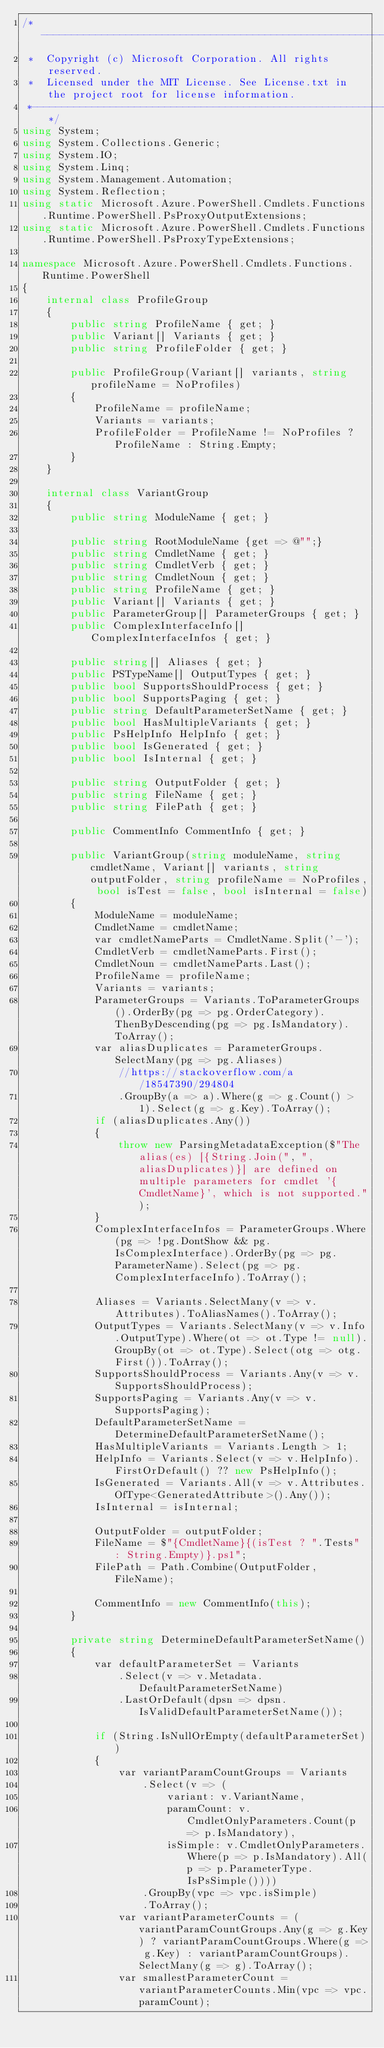Convert code to text. <code><loc_0><loc_0><loc_500><loc_500><_C#_>/*---------------------------------------------------------------------------------------------
 *  Copyright (c) Microsoft Corporation. All rights reserved.
 *  Licensed under the MIT License. See License.txt in the project root for license information.
 *--------------------------------------------------------------------------------------------*/
using System;
using System.Collections.Generic;
using System.IO;
using System.Linq;
using System.Management.Automation;
using System.Reflection;
using static Microsoft.Azure.PowerShell.Cmdlets.Functions.Runtime.PowerShell.PsProxyOutputExtensions;
using static Microsoft.Azure.PowerShell.Cmdlets.Functions.Runtime.PowerShell.PsProxyTypeExtensions;

namespace Microsoft.Azure.PowerShell.Cmdlets.Functions.Runtime.PowerShell
{
    internal class ProfileGroup
    {
        public string ProfileName { get; }
        public Variant[] Variants { get; }
        public string ProfileFolder { get; }

        public ProfileGroup(Variant[] variants, string profileName = NoProfiles)
        {
            ProfileName = profileName;
            Variants = variants;
            ProfileFolder = ProfileName != NoProfiles ? ProfileName : String.Empty;
        }
    }

    internal class VariantGroup
    {
        public string ModuleName { get; }

        public string RootModuleName {get => @"";}
        public string CmdletName { get; }
        public string CmdletVerb { get; }
        public string CmdletNoun { get; }
        public string ProfileName { get; }
        public Variant[] Variants { get; }
        public ParameterGroup[] ParameterGroups { get; }
        public ComplexInterfaceInfo[] ComplexInterfaceInfos { get; }

        public string[] Aliases { get; }
        public PSTypeName[] OutputTypes { get; }
        public bool SupportsShouldProcess { get; }
        public bool SupportsPaging { get; }
        public string DefaultParameterSetName { get; }
        public bool HasMultipleVariants { get; }
        public PsHelpInfo HelpInfo { get; }
        public bool IsGenerated { get; }
        public bool IsInternal { get; }

        public string OutputFolder { get; }
        public string FileName { get; }
        public string FilePath { get; }

        public CommentInfo CommentInfo { get; }

        public VariantGroup(string moduleName, string cmdletName, Variant[] variants, string outputFolder, string profileName = NoProfiles, bool isTest = false, bool isInternal = false)
        {
            ModuleName = moduleName;
            CmdletName = cmdletName;
            var cmdletNameParts = CmdletName.Split('-');
            CmdletVerb = cmdletNameParts.First();
            CmdletNoun = cmdletNameParts.Last();
            ProfileName = profileName;
            Variants = variants;
            ParameterGroups = Variants.ToParameterGroups().OrderBy(pg => pg.OrderCategory).ThenByDescending(pg => pg.IsMandatory).ToArray();
            var aliasDuplicates = ParameterGroups.SelectMany(pg => pg.Aliases)
                //https://stackoverflow.com/a/18547390/294804
                .GroupBy(a => a).Where(g => g.Count() > 1).Select(g => g.Key).ToArray();
            if (aliasDuplicates.Any())
            {
                throw new ParsingMetadataException($"The alias(es) [{String.Join(", ", aliasDuplicates)}] are defined on multiple parameters for cmdlet '{CmdletName}', which is not supported.");
            }
            ComplexInterfaceInfos = ParameterGroups.Where(pg => !pg.DontShow && pg.IsComplexInterface).OrderBy(pg => pg.ParameterName).Select(pg => pg.ComplexInterfaceInfo).ToArray();

            Aliases = Variants.SelectMany(v => v.Attributes).ToAliasNames().ToArray();
            OutputTypes = Variants.SelectMany(v => v.Info.OutputType).Where(ot => ot.Type != null).GroupBy(ot => ot.Type).Select(otg => otg.First()).ToArray();
            SupportsShouldProcess = Variants.Any(v => v.SupportsShouldProcess);
            SupportsPaging = Variants.Any(v => v.SupportsPaging);
            DefaultParameterSetName = DetermineDefaultParameterSetName();
            HasMultipleVariants = Variants.Length > 1;
            HelpInfo = Variants.Select(v => v.HelpInfo).FirstOrDefault() ?? new PsHelpInfo();
            IsGenerated = Variants.All(v => v.Attributes.OfType<GeneratedAttribute>().Any());
            IsInternal = isInternal;

            OutputFolder = outputFolder;
            FileName = $"{CmdletName}{(isTest ? ".Tests" : String.Empty)}.ps1";
            FilePath = Path.Combine(OutputFolder, FileName);

            CommentInfo = new CommentInfo(this);
        }

        private string DetermineDefaultParameterSetName()
        {
            var defaultParameterSet = Variants
                .Select(v => v.Metadata.DefaultParameterSetName)
                .LastOrDefault(dpsn => dpsn.IsValidDefaultParameterSetName());

            if (String.IsNullOrEmpty(defaultParameterSet))
            {
                var variantParamCountGroups = Variants
                    .Select(v => (
                        variant: v.VariantName,
                        paramCount: v.CmdletOnlyParameters.Count(p => p.IsMandatory),
                        isSimple: v.CmdletOnlyParameters.Where(p => p.IsMandatory).All(p => p.ParameterType.IsPsSimple())))
                    .GroupBy(vpc => vpc.isSimple)
                    .ToArray();
                var variantParameterCounts = (variantParamCountGroups.Any(g => g.Key) ? variantParamCountGroups.Where(g => g.Key) : variantParamCountGroups).SelectMany(g => g).ToArray();
                var smallestParameterCount = variantParameterCounts.Min(vpc => vpc.paramCount);</code> 